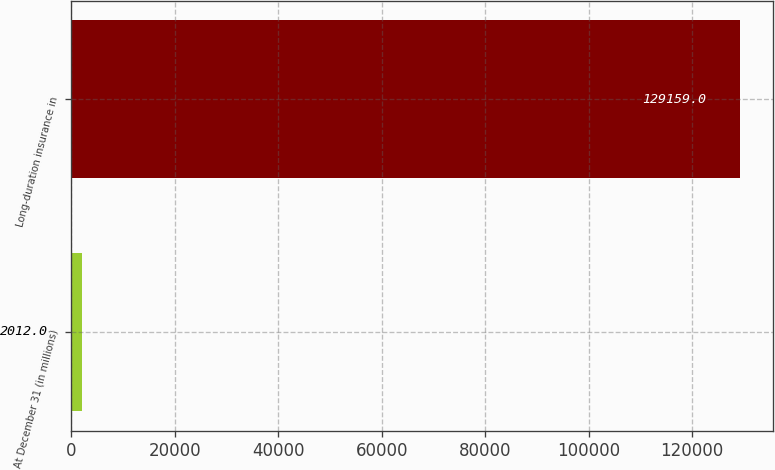Convert chart. <chart><loc_0><loc_0><loc_500><loc_500><bar_chart><fcel>At December 31 (in millions)<fcel>Long-duration insurance in<nl><fcel>2012<fcel>129159<nl></chart> 